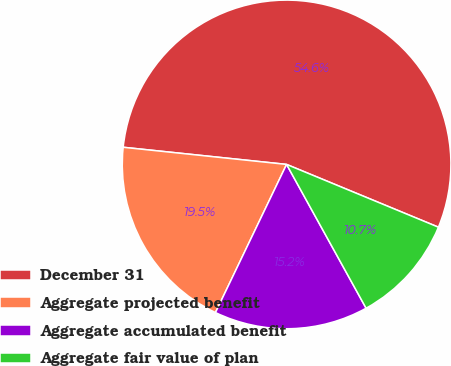Convert chart to OTSL. <chart><loc_0><loc_0><loc_500><loc_500><pie_chart><fcel>December 31<fcel>Aggregate projected benefit<fcel>Aggregate accumulated benefit<fcel>Aggregate fair value of plan<nl><fcel>54.57%<fcel>19.54%<fcel>15.16%<fcel>10.72%<nl></chart> 